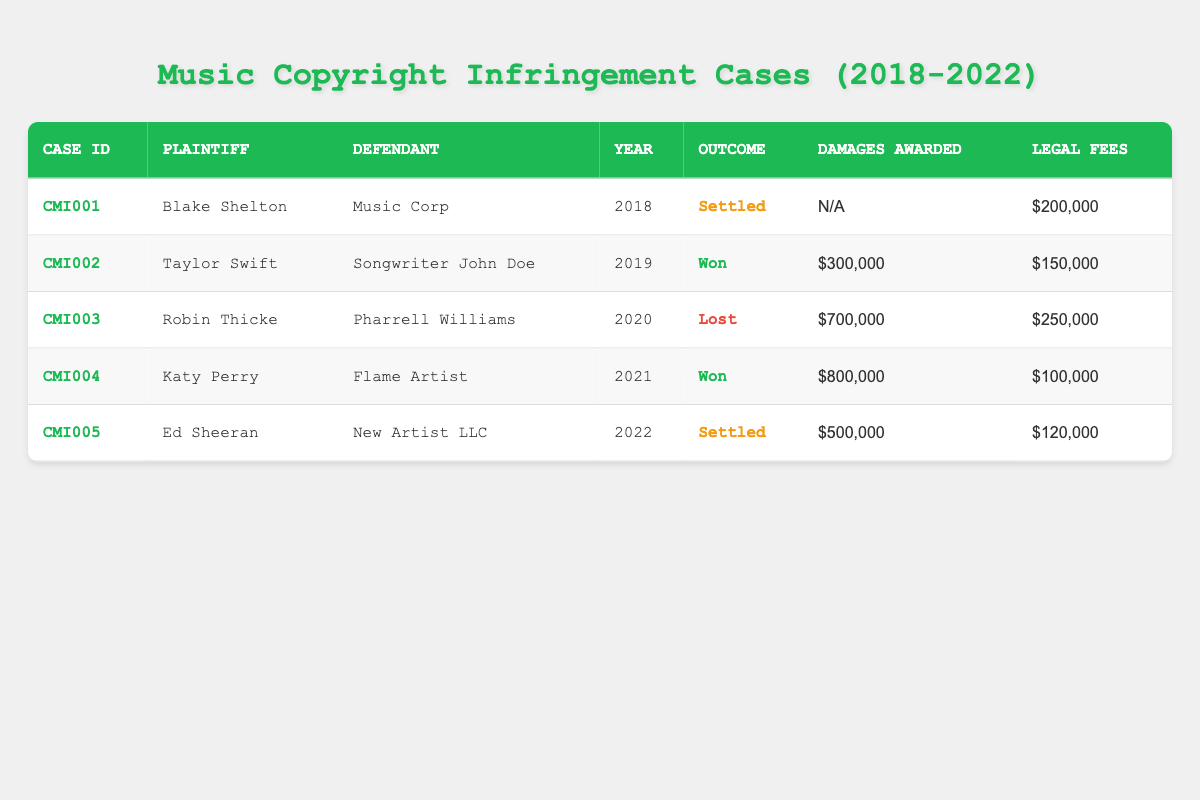What was the outcome of the case filed by Taylor Swift? Taylor Swift's case is identified as "CMI002" in the table. The outcome column for this case shows "Won."
Answer: Won How much were the legal fees for Robin Thicke's case? In the row for Robin Thicke's case (CMI003), the legal fees listed are "$250,000."
Answer: $250,000 Was Ed Sheeran's case settled? Ed Sheeran's case (CMI005) has the outcome listed as "Settled," confirming it was indeed settled.
Answer: Yes What is the total amount of damages awarded across all cases? The damages awarded are $300,000 (Taylor Swift) + $700,000 (Robin Thicke) + $800,000 (Katy Perry) + $500,000 (Ed Sheeran) = $2,300,000. The case filed by Blake Shelton had no damages awarded.
Answer: $2,300,000 Which plaintiff had the highest legal fees and how much were they? The highest legal fees are found in Robin Thicke's case with $250,000. Comparing all the legal fees: $200,000 (Blake Shelton), $150,000 (Taylor Swift), $250,000 (Robin Thicke), $100,000 (Katy Perry), and $120,000 (Ed Sheeran), Robin Thicke has the highest.
Answer: Robin Thicke, $250,000 In what year did Katy Perry win her case? The table lists Katy Perry's case (CMI004) under the year column as "2021," indicating that she won her case in that year.
Answer: 2021 What percentage of the cases were settled? There are a total of 5 cases. Two cases (CMI001 and CMI005) are settled, so the percentage is (2/5) * 100 = 40%.
Answer: 40% Did any case result in a loss? Looking through the outcomes, Robin Thicke's case (CMI003) shows "Lost," confirming there was indeed a case that resulted in a loss.
Answer: Yes How many cases were filed in the year 2020? There is only one case filed in 2020, which is Robin Thicke's case (CMI003). Hence, the count is 1.
Answer: 1 What was the difference in legal fees between the case with the highest outcome award and the lowest? The highest damages awarded were in Katy Perry's case ($800,000) and the lowest were in Blake Shelton's case (which had $0 awarded). The difference in legal fees is $250,000 (Robin Thicke) - $200,000 (Blake Shelton) = $50,000. The outcome award difference here is $800,000 - $0 = $800,000. However, for legal fees, it’s $250,000 - $100,000 = $150,000.
Answer: $150,000 